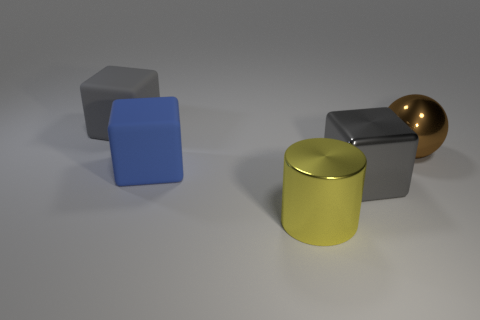What number of large brown metallic objects have the same shape as the big gray matte object?
Provide a succinct answer. 0. The big object that is in front of the gray block to the right of the big metal cylinder is made of what material?
Offer a terse response. Metal. There is a gray thing that is right of the big blue cube; what is its size?
Provide a short and direct response. Large. How many yellow things are large metal cylinders or balls?
Provide a succinct answer. 1. Are there any other things that have the same material as the big cylinder?
Your answer should be compact. Yes. What is the material of the other gray thing that is the same shape as the big gray metallic object?
Offer a terse response. Rubber. Is the number of gray matte objects in front of the yellow metal thing the same as the number of brown metallic things?
Make the answer very short. No. What size is the object that is on the left side of the big metal cylinder and in front of the big gray matte block?
Offer a very short reply. Large. Are there any other things of the same color as the sphere?
Give a very brief answer. No. How big is the object that is in front of the large gray cube that is to the right of the large metal cylinder?
Offer a terse response. Large. 